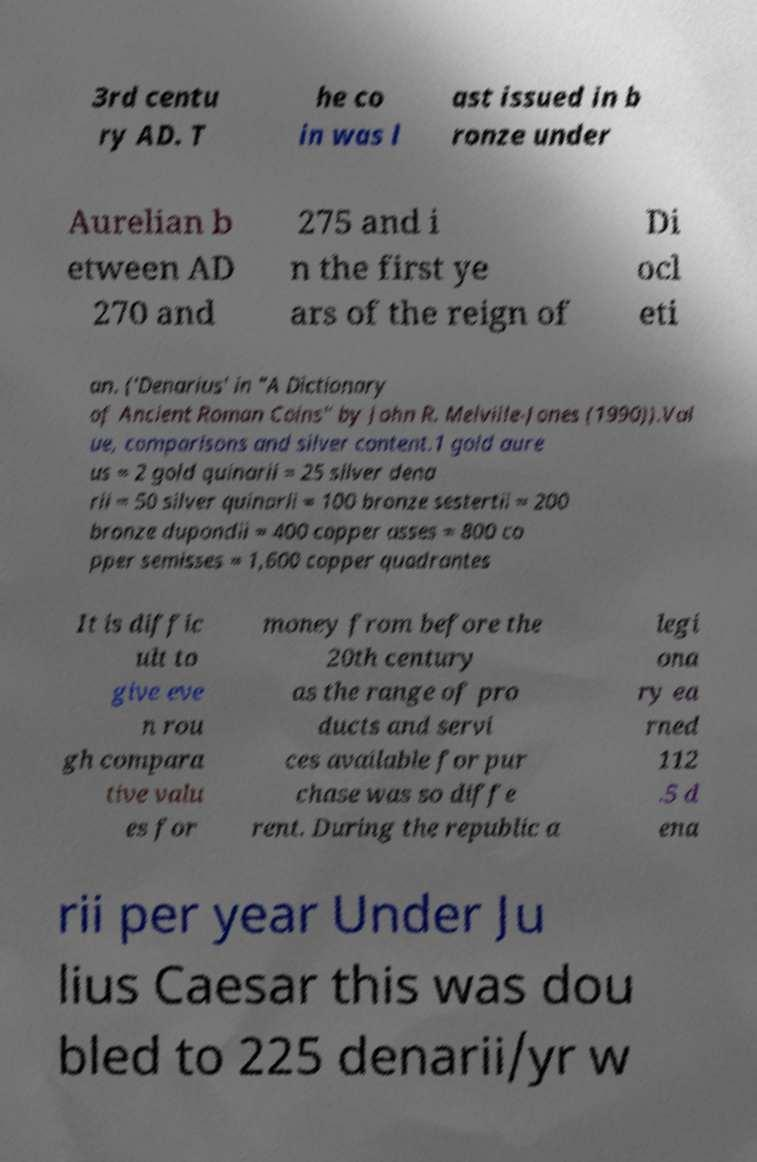Could you extract and type out the text from this image? 3rd centu ry AD. T he co in was l ast issued in b ronze under Aurelian b etween AD 270 and 275 and i n the first ye ars of the reign of Di ocl eti an. ('Denarius' in "A Dictionary of Ancient Roman Coins" by John R. Melville-Jones (1990)).Val ue, comparisons and silver content.1 gold aure us = 2 gold quinarii = 25 silver dena rii = 50 silver quinarii = 100 bronze sestertii = 200 bronze dupondii = 400 copper asses = 800 co pper semisses = 1,600 copper quadrantes It is diffic ult to give eve n rou gh compara tive valu es for money from before the 20th century as the range of pro ducts and servi ces available for pur chase was so diffe rent. During the republic a legi ona ry ea rned 112 .5 d ena rii per year Under Ju lius Caesar this was dou bled to 225 denarii/yr w 